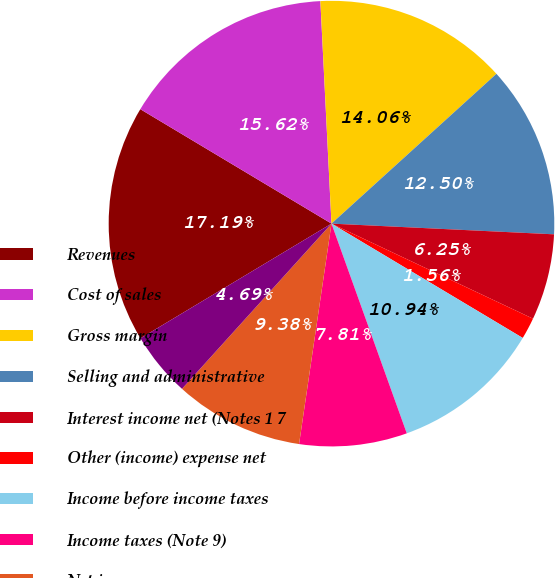Convert chart. <chart><loc_0><loc_0><loc_500><loc_500><pie_chart><fcel>Revenues<fcel>Cost of sales<fcel>Gross margin<fcel>Selling and administrative<fcel>Interest income net (Notes 1 7<fcel>Other (income) expense net<fcel>Income before income taxes<fcel>Income taxes (Note 9)<fcel>Net income<fcel>Basic earnings per common<nl><fcel>17.19%<fcel>15.62%<fcel>14.06%<fcel>12.5%<fcel>6.25%<fcel>1.56%<fcel>10.94%<fcel>7.81%<fcel>9.38%<fcel>4.69%<nl></chart> 